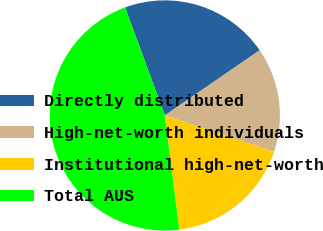<chart> <loc_0><loc_0><loc_500><loc_500><pie_chart><fcel>Directly distributed<fcel>High-net-worth individuals<fcel>Institutional high-net-worth<fcel>Total AUS<nl><fcel>21.04%<fcel>14.7%<fcel>17.87%<fcel>46.4%<nl></chart> 